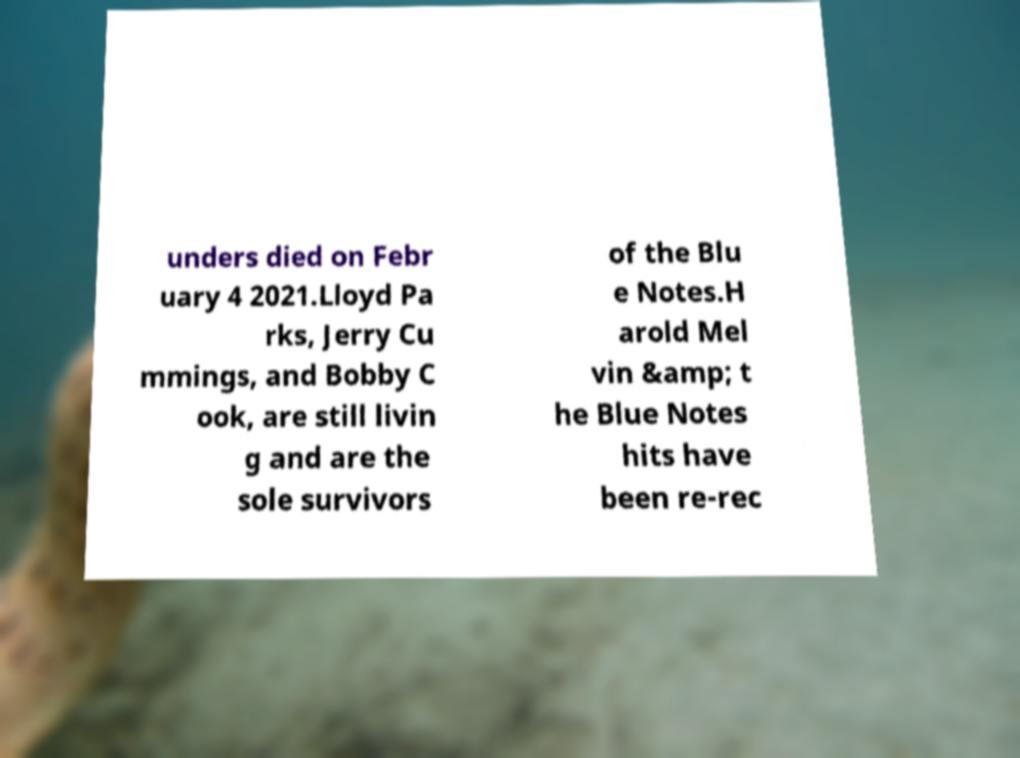Could you assist in decoding the text presented in this image and type it out clearly? unders died on Febr uary 4 2021.Lloyd Pa rks, Jerry Cu mmings, and Bobby C ook, are still livin g and are the sole survivors of the Blu e Notes.H arold Mel vin &amp; t he Blue Notes hits have been re-rec 